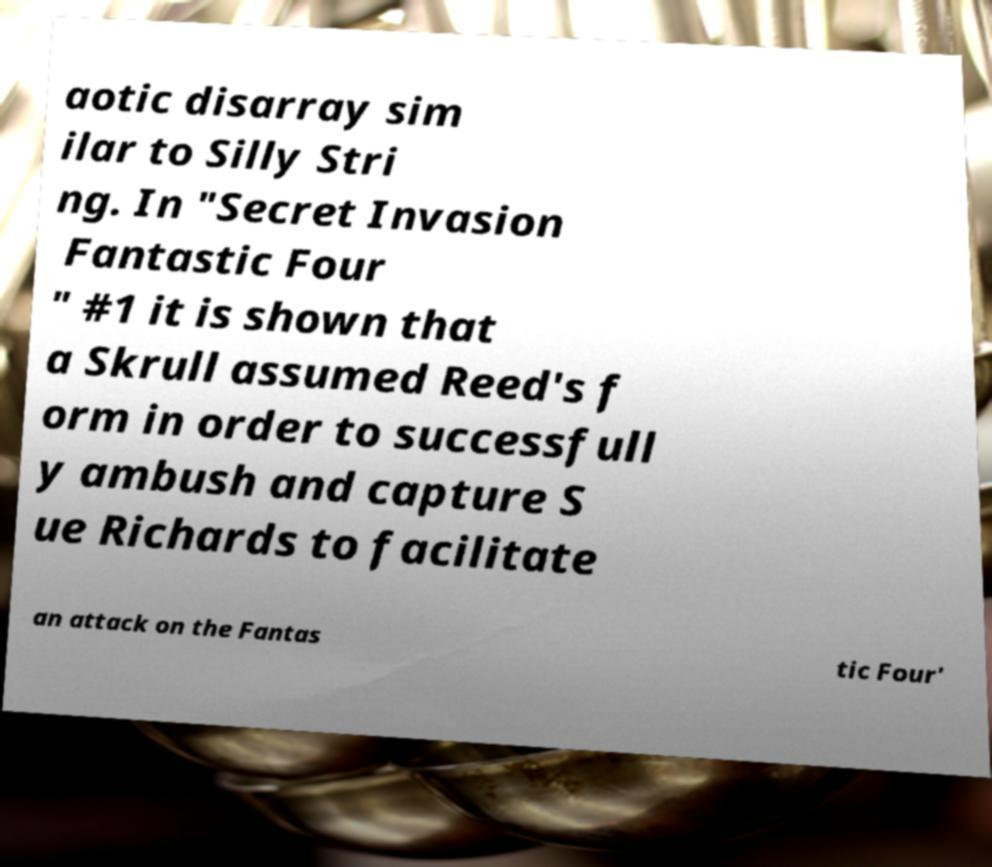Please identify and transcribe the text found in this image. aotic disarray sim ilar to Silly Stri ng. In "Secret Invasion Fantastic Four " #1 it is shown that a Skrull assumed Reed's f orm in order to successfull y ambush and capture S ue Richards to facilitate an attack on the Fantas tic Four' 